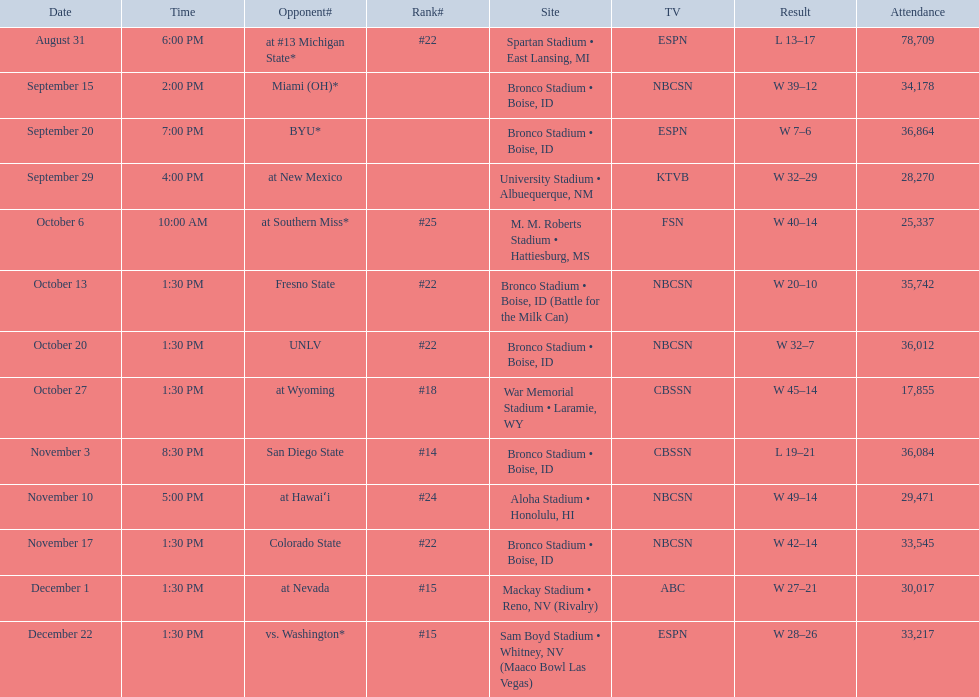Who were all the adversaries? At #13 michigan state*, miami (oh)*, byu*, at new mexico, at southern miss*, fresno state, unlv, at wyoming, san diego state, at hawaiʻi, colorado state, at nevada, vs. washington*. Who did they confront on november 3rd? San Diego State. What position were they in on november 3rd? #14. 